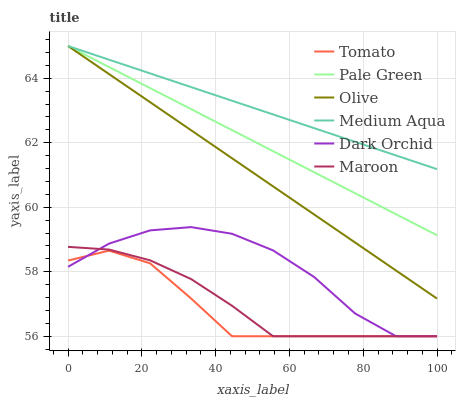Does Tomato have the minimum area under the curve?
Answer yes or no. Yes. Does Medium Aqua have the maximum area under the curve?
Answer yes or no. Yes. Does Maroon have the minimum area under the curve?
Answer yes or no. No. Does Maroon have the maximum area under the curve?
Answer yes or no. No. Is Pale Green the smoothest?
Answer yes or no. Yes. Is Dark Orchid the roughest?
Answer yes or no. Yes. Is Maroon the smoothest?
Answer yes or no. No. Is Maroon the roughest?
Answer yes or no. No. Does Tomato have the lowest value?
Answer yes or no. Yes. Does Pale Green have the lowest value?
Answer yes or no. No. Does Olive have the highest value?
Answer yes or no. Yes. Does Maroon have the highest value?
Answer yes or no. No. Is Maroon less than Pale Green?
Answer yes or no. Yes. Is Olive greater than Dark Orchid?
Answer yes or no. Yes. Does Medium Aqua intersect Olive?
Answer yes or no. Yes. Is Medium Aqua less than Olive?
Answer yes or no. No. Is Medium Aqua greater than Olive?
Answer yes or no. No. Does Maroon intersect Pale Green?
Answer yes or no. No. 